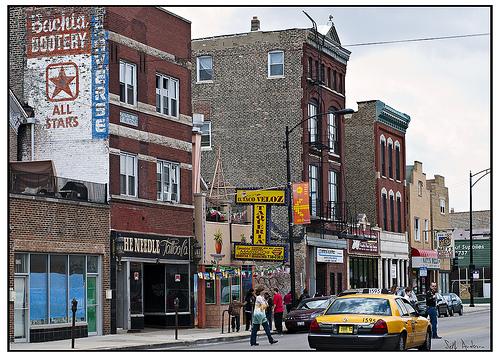Is this a photo taken in the United States?
Short answer required. Yes. What is the billboard advertising?
Answer briefly. All stars. How many stories is the tallest building in the photo?
Keep it brief. 4. What is the taxi number?
Short answer required. 1595. What are those yellow things in the road?
Keep it brief. Taxi. Is the man standing in the road?
Write a very short answer. Yes. 